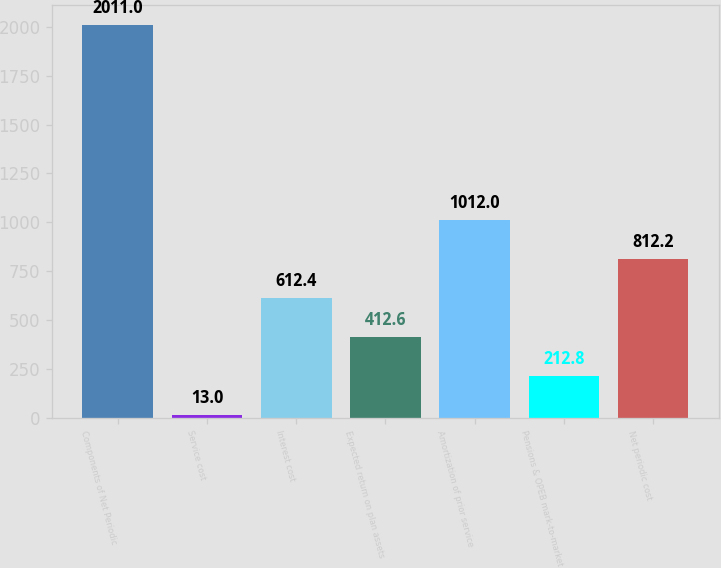<chart> <loc_0><loc_0><loc_500><loc_500><bar_chart><fcel>Components of Net Periodic<fcel>Service cost<fcel>Interest cost<fcel>Expected return on plan assets<fcel>Amortization of prior service<fcel>Pensions & OPEB mark-to-market<fcel>Net periodic cost<nl><fcel>2011<fcel>13<fcel>612.4<fcel>412.6<fcel>1012<fcel>212.8<fcel>812.2<nl></chart> 